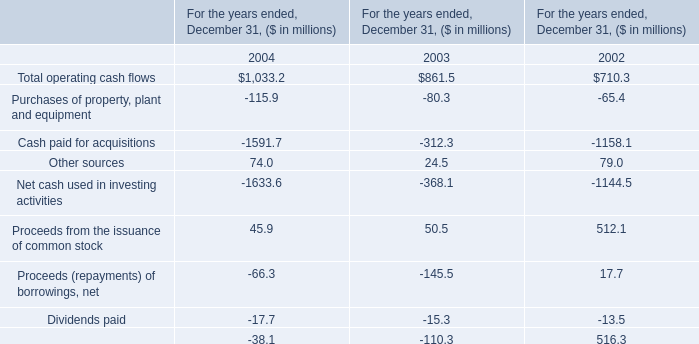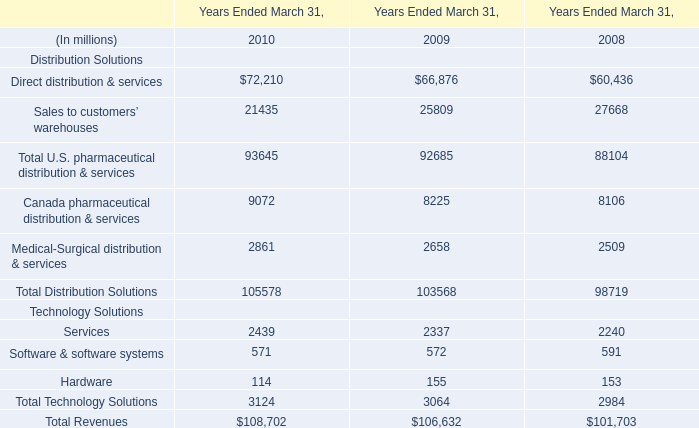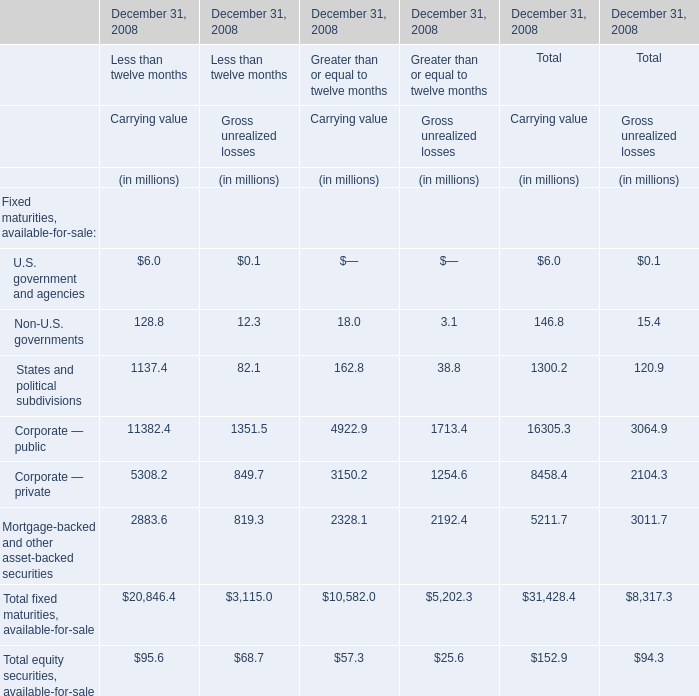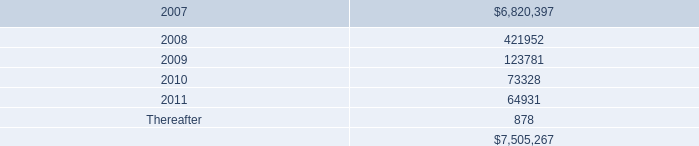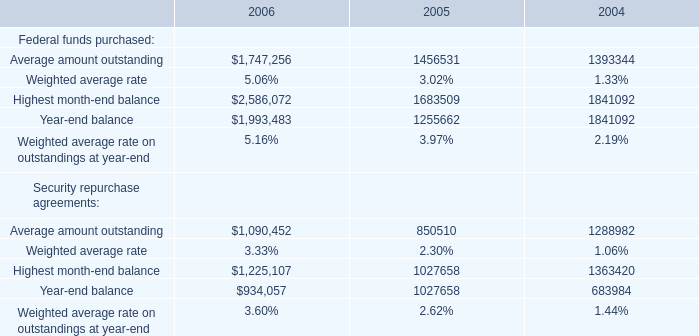What's the sum of all Carrying value that are positive in 2008 for Greater than or equal to twelve months? (in million) 
Computations: (((((18.0 + 162.8) + 4922.9) + 3150.2) + 2328.1) + 57.3)
Answer: 10639.3. 